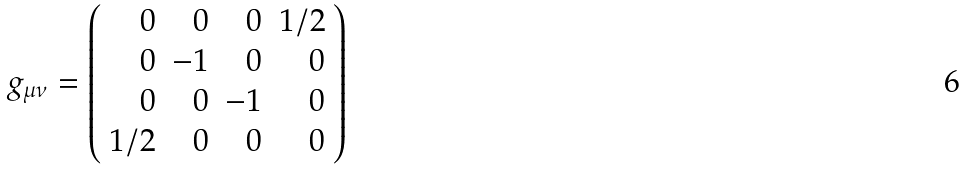<formula> <loc_0><loc_0><loc_500><loc_500>g _ { \mu \nu } = \left ( \begin{array} { r r r r } 0 & 0 & 0 & 1 / 2 \\ 0 & - 1 & 0 & 0 \\ 0 & 0 & - 1 & 0 \\ 1 / 2 & 0 & 0 & 0 \end{array} \right )</formula> 